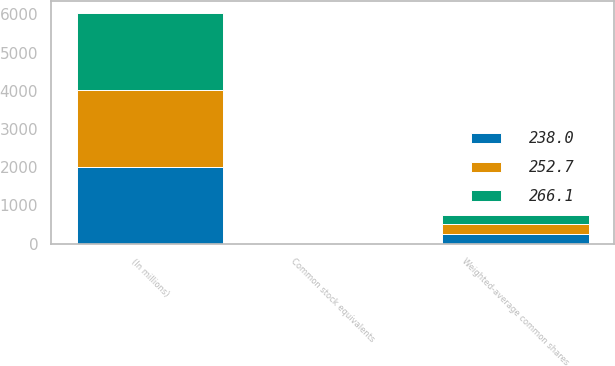<chart> <loc_0><loc_0><loc_500><loc_500><stacked_bar_chart><ecel><fcel>(In millions)<fcel>Weighted-average common shares<fcel>Common stock equivalents<nl><fcel>252.7<fcel>2015<fcel>238<fcel>4.1<nl><fcel>266.1<fcel>2014<fcel>252.7<fcel>4.1<nl><fcel>238<fcel>2013<fcel>266.1<fcel>3.7<nl></chart> 